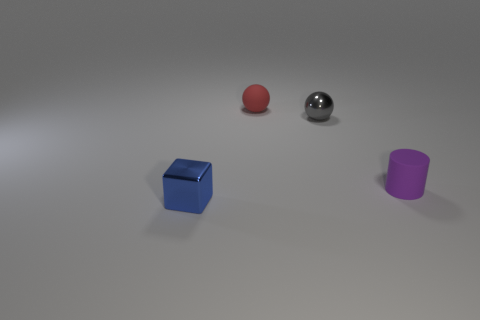What can you tell me about the lighting and shadows in the scene? The image showcases a soft and diffused lighting setup, with the shadows of the objects gently cast to the right, indicating that the primary light source is to the left. The shadows are soft-edged with no harsh lines, suggesting that the environment might have ambient lighting or a large light source. 